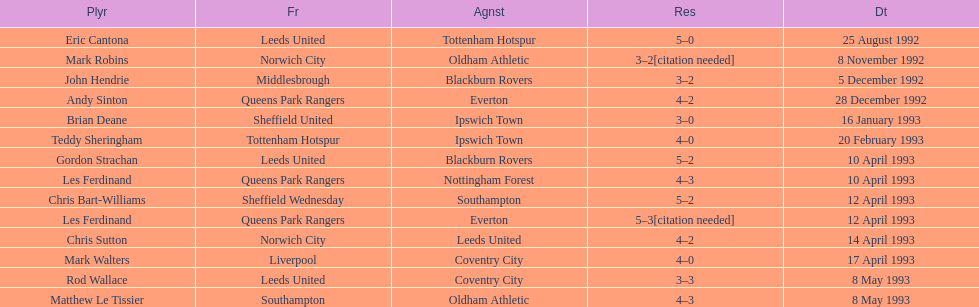Who does john hendrie play for? Middlesbrough. 